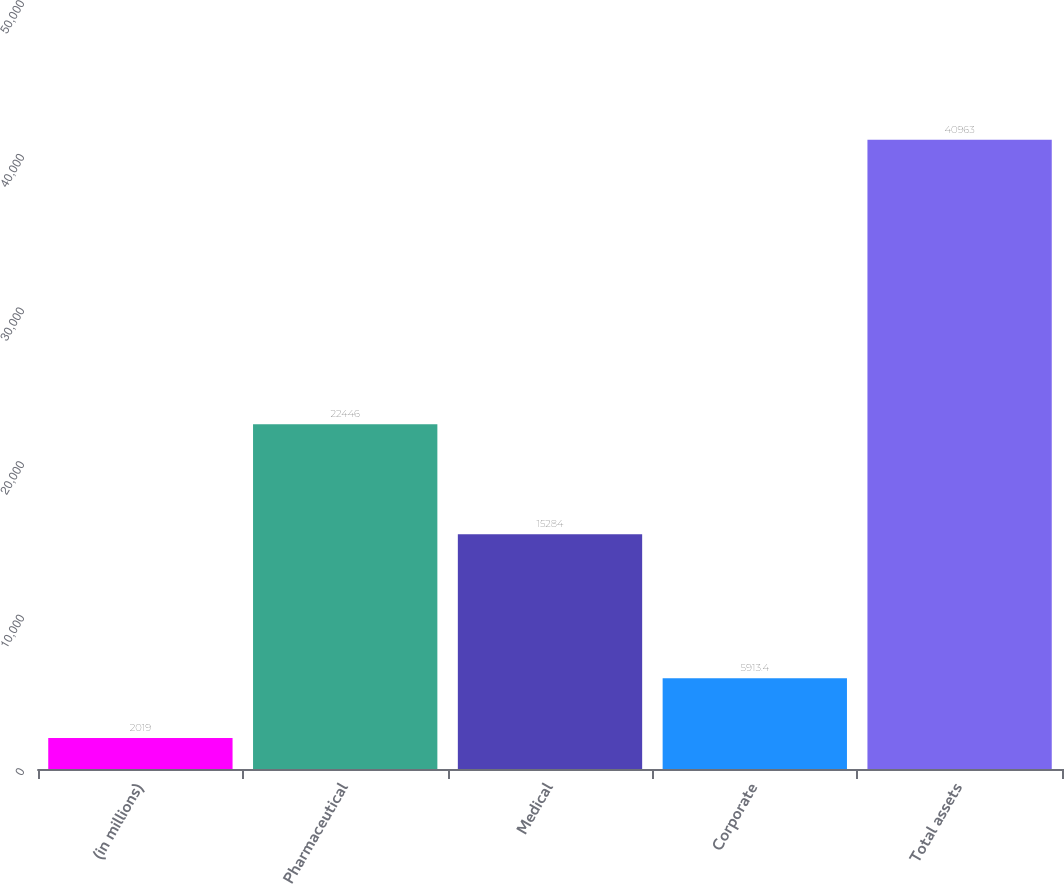Convert chart. <chart><loc_0><loc_0><loc_500><loc_500><bar_chart><fcel>(in millions)<fcel>Pharmaceutical<fcel>Medical<fcel>Corporate<fcel>Total assets<nl><fcel>2019<fcel>22446<fcel>15284<fcel>5913.4<fcel>40963<nl></chart> 